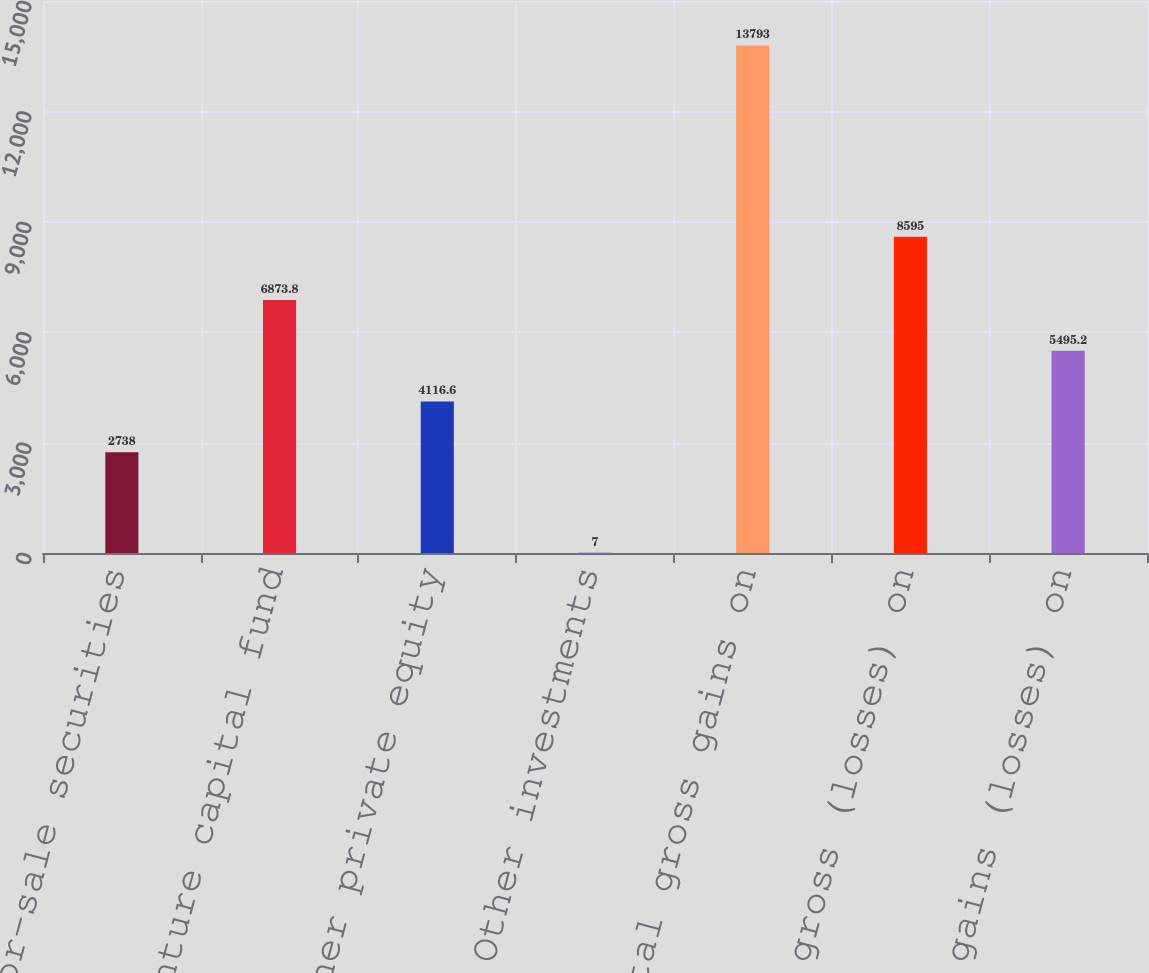<chart> <loc_0><loc_0><loc_500><loc_500><bar_chart><fcel>Available-for-sale securities<fcel>Venture capital fund<fcel>Other private equity<fcel>Other investments<fcel>Total gross gains on<fcel>Total gross (losses) on<fcel>Net gains (losses) on<nl><fcel>2738<fcel>6873.8<fcel>4116.6<fcel>7<fcel>13793<fcel>8595<fcel>5495.2<nl></chart> 